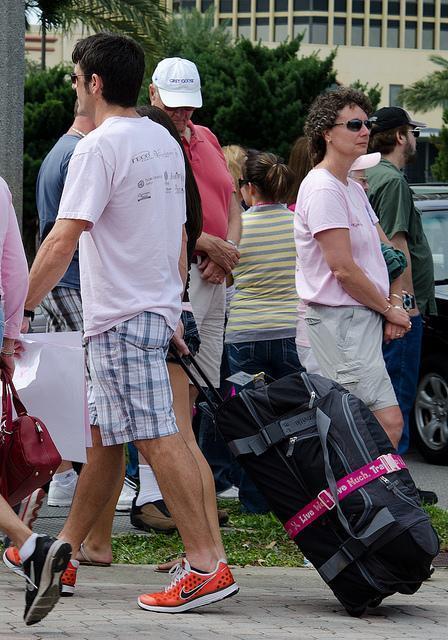How many handbags are visible?
Give a very brief answer. 1. How many people can be seen?
Give a very brief answer. 8. 